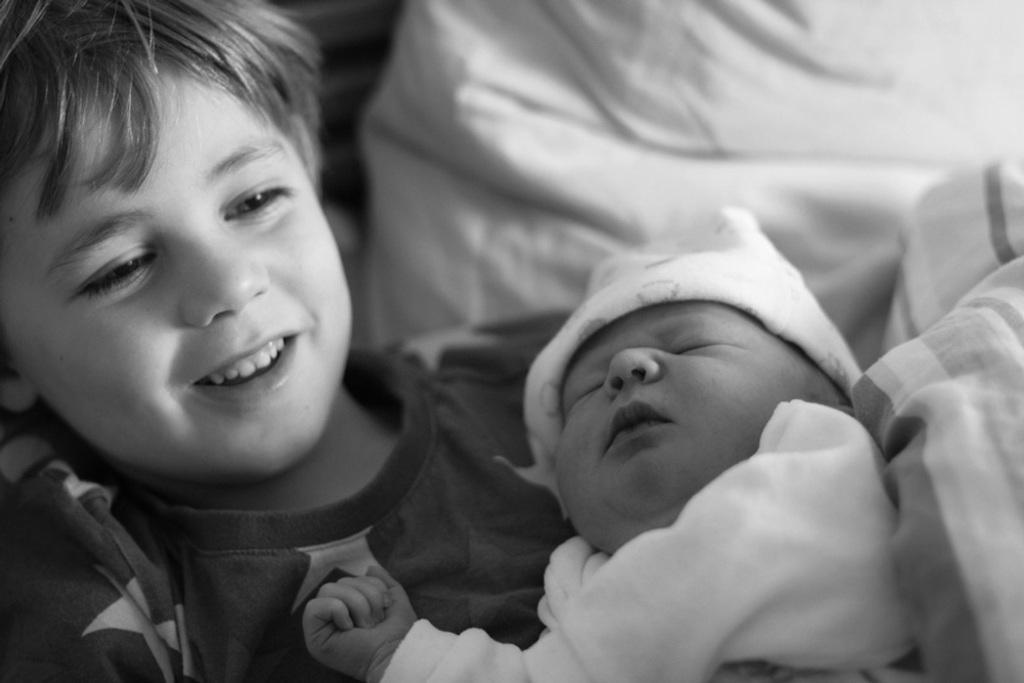Please provide a concise description of this image. This is a black and white image. There is a boy carrying a baby. In the background of the image there is a white color cloth. 